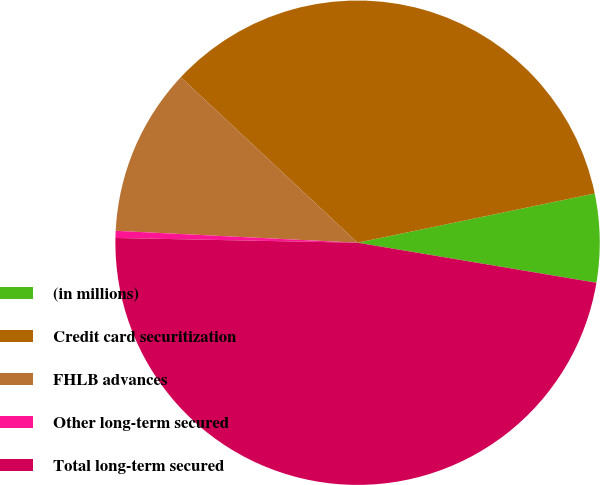Convert chart. <chart><loc_0><loc_0><loc_500><loc_500><pie_chart><fcel>(in millions)<fcel>Credit card securitization<fcel>FHLB advances<fcel>Other long-term secured<fcel>Total long-term secured<nl><fcel>5.9%<fcel>34.77%<fcel>11.19%<fcel>0.47%<fcel>47.67%<nl></chart> 